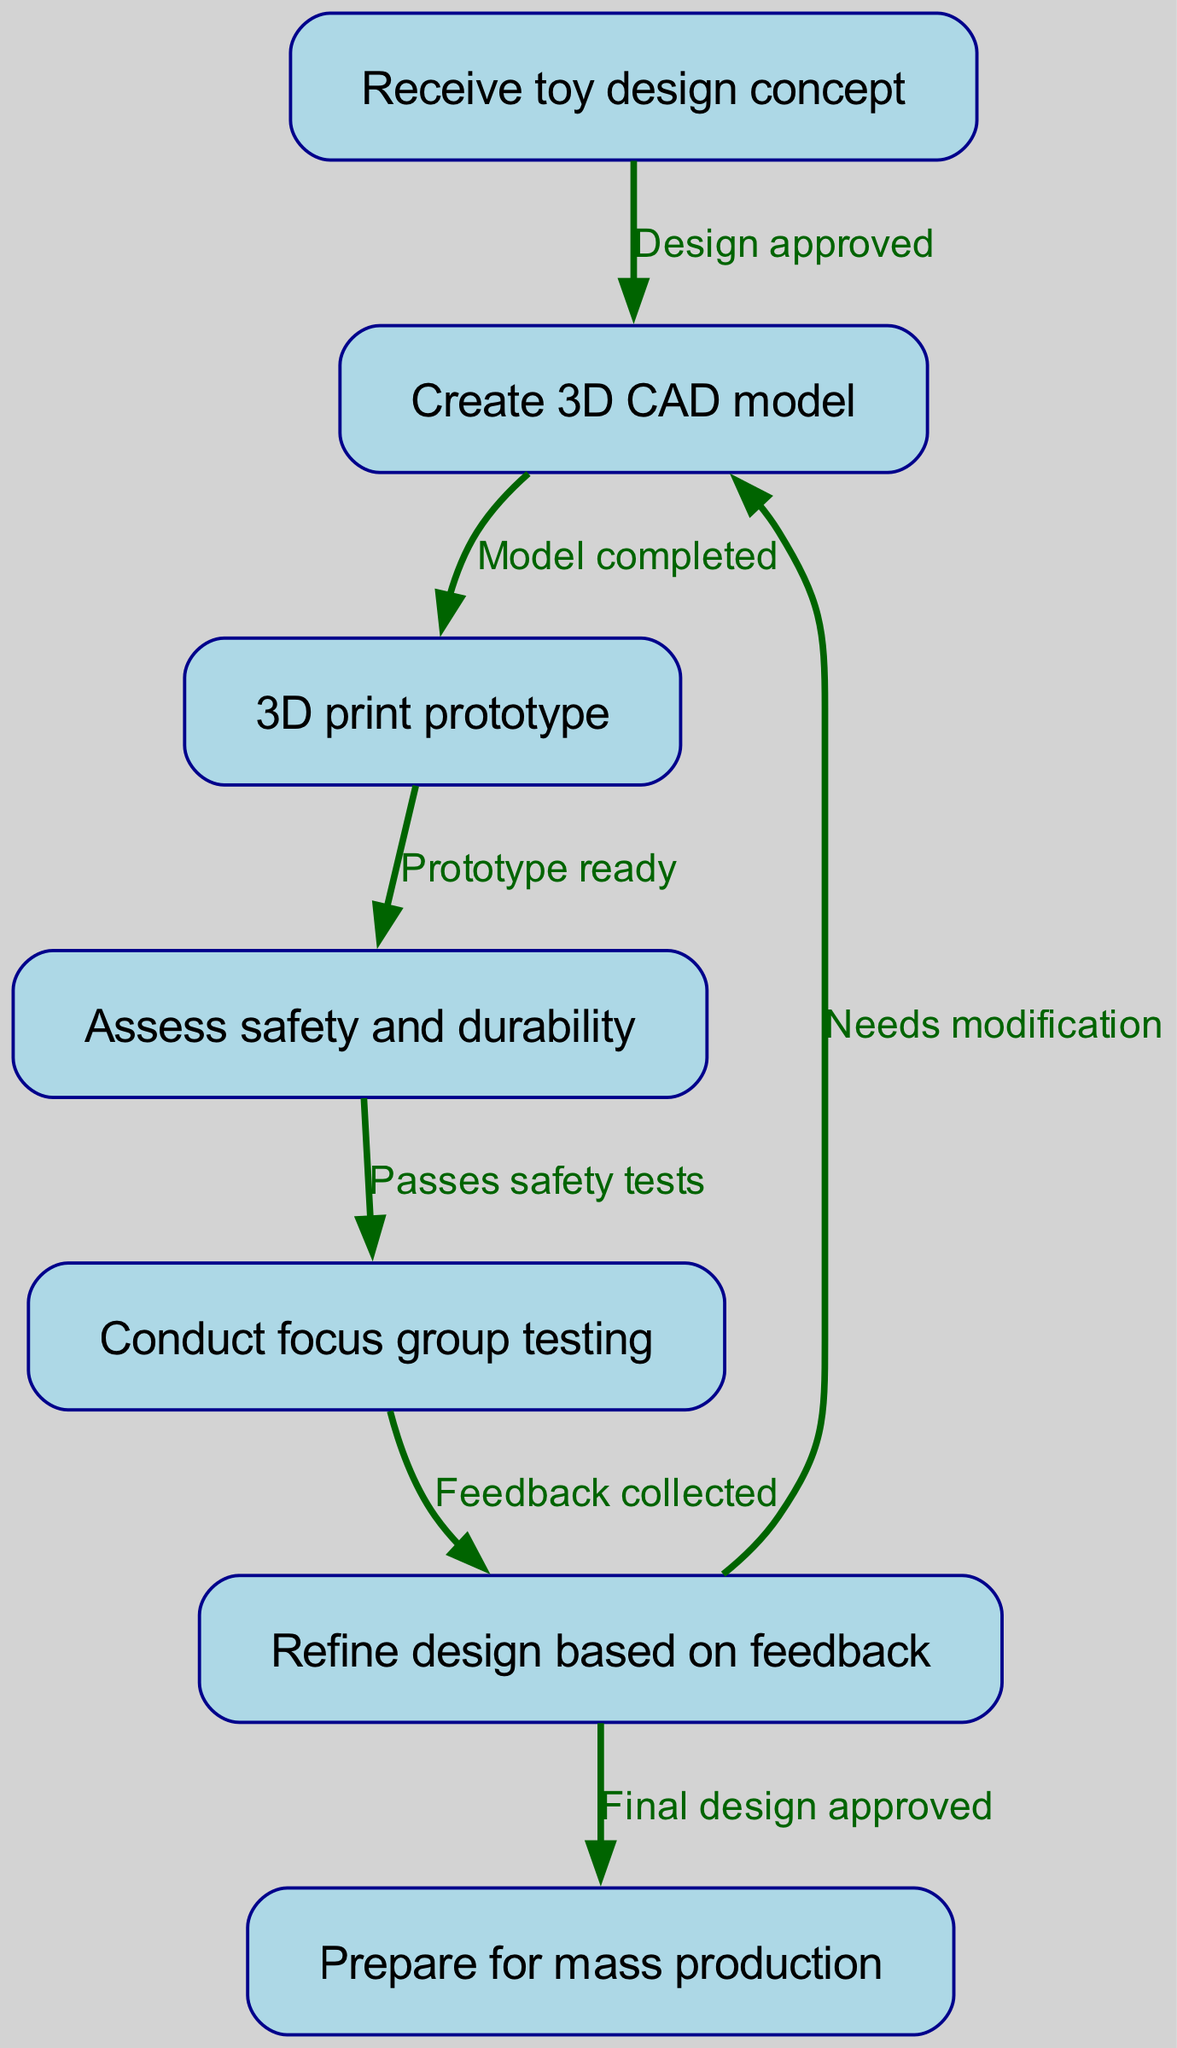What is the first step in the workflow? The first step in the workflow is represented by the node labeled "Receive toy design concept." This is the initial action that kicks off the entire process.
Answer: Receive toy design concept How many nodes are in the diagram? By counting each of the unique steps (nodes) present in the diagram, I find there are seven distinct nodes related to stages in the prototype development.
Answer: 7 What step follows "3D print prototype"? The step that directly follows "3D print prototype" is represented by the node labeled "Assess safety and durability." This indicates the next action that occurs after 3D printing.
Answer: Assess safety and durability What happens if the design needs modification? If the design needs modification, the workflow indicates that it returns to the "Create 3D CAD model" step. This shows that feedback can send the design back for adjustments before further processing.
Answer: Create 3D CAD model How does "Conduct focus group testing" relate to "Assess safety and durability"? The node "Conduct focus group testing" receives input only after the prototype has passed the safety tests at "Assess safety and durability," showing a dependence on the earlier step for the testing process.
Answer: Passes safety tests What is the relationship described when transitioning from "Refine design based on feedback" to "Prepare for mass production"? The transition from "Refine design based on feedback" to "Prepare for mass production" indicates a successful flow where the final design has been approved after feedback from focus group testing, leading to readiness for production.
Answer: Final design approved 